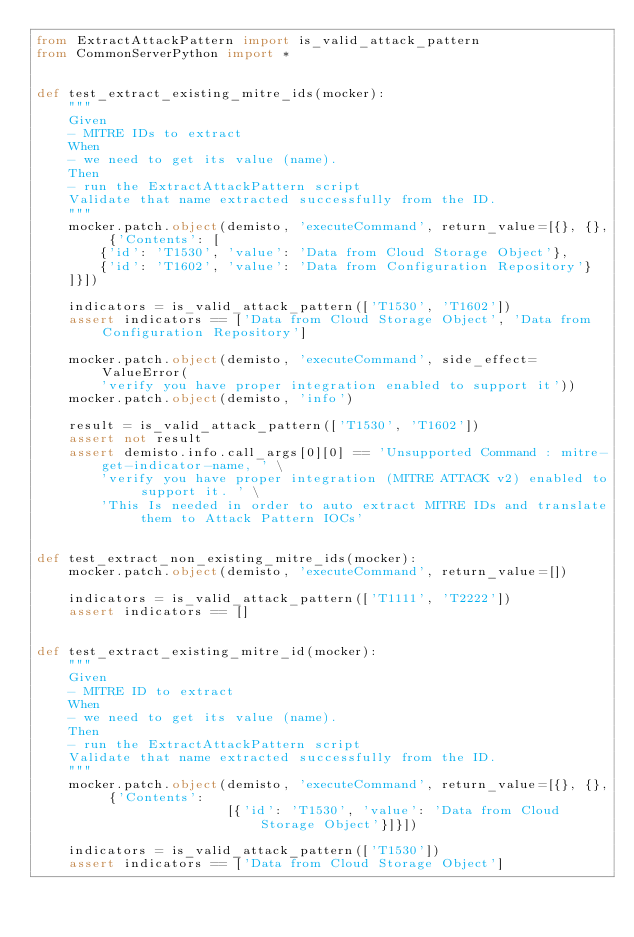Convert code to text. <code><loc_0><loc_0><loc_500><loc_500><_Python_>from ExtractAttackPattern import is_valid_attack_pattern
from CommonServerPython import *


def test_extract_existing_mitre_ids(mocker):
    """
    Given
    - MITRE IDs to extract
    When
    - we need to get its value (name).
    Then
    - run the ExtractAttackPattern script
    Validate that name extracted successfully from the ID.
    """
    mocker.patch.object(demisto, 'executeCommand', return_value=[{}, {}, {'Contents': [
        {'id': 'T1530', 'value': 'Data from Cloud Storage Object'},
        {'id': 'T1602', 'value': 'Data from Configuration Repository'}
    ]}])

    indicators = is_valid_attack_pattern(['T1530', 'T1602'])
    assert indicators == ['Data from Cloud Storage Object', 'Data from Configuration Repository']

    mocker.patch.object(demisto, 'executeCommand', side_effect=ValueError(
        'verify you have proper integration enabled to support it'))
    mocker.patch.object(demisto, 'info')

    result = is_valid_attack_pattern(['T1530', 'T1602'])
    assert not result
    assert demisto.info.call_args[0][0] == 'Unsupported Command : mitre-get-indicator-name, ' \
        'verify you have proper integration (MITRE ATTACK v2) enabled to support it. ' \
        'This Is needed in order to auto extract MITRE IDs and translate them to Attack Pattern IOCs'


def test_extract_non_existing_mitre_ids(mocker):
    mocker.patch.object(demisto, 'executeCommand', return_value=[])

    indicators = is_valid_attack_pattern(['T1111', 'T2222'])
    assert indicators == []


def test_extract_existing_mitre_id(mocker):
    """
    Given
    - MITRE ID to extract
    When
    - we need to get its value (name).
    Then
    - run the ExtractAttackPattern script
    Validate that name extracted successfully from the ID.
    """
    mocker.patch.object(demisto, 'executeCommand', return_value=[{}, {}, {'Contents':
                        [{'id': 'T1530', 'value': 'Data from Cloud Storage Object'}]}])

    indicators = is_valid_attack_pattern(['T1530'])
    assert indicators == ['Data from Cloud Storage Object']
</code> 